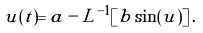Convert formula to latex. <formula><loc_0><loc_0><loc_500><loc_500>u ( t ) = a - L ^ { - 1 } [ b \sin ( u ) ] \, .</formula> 